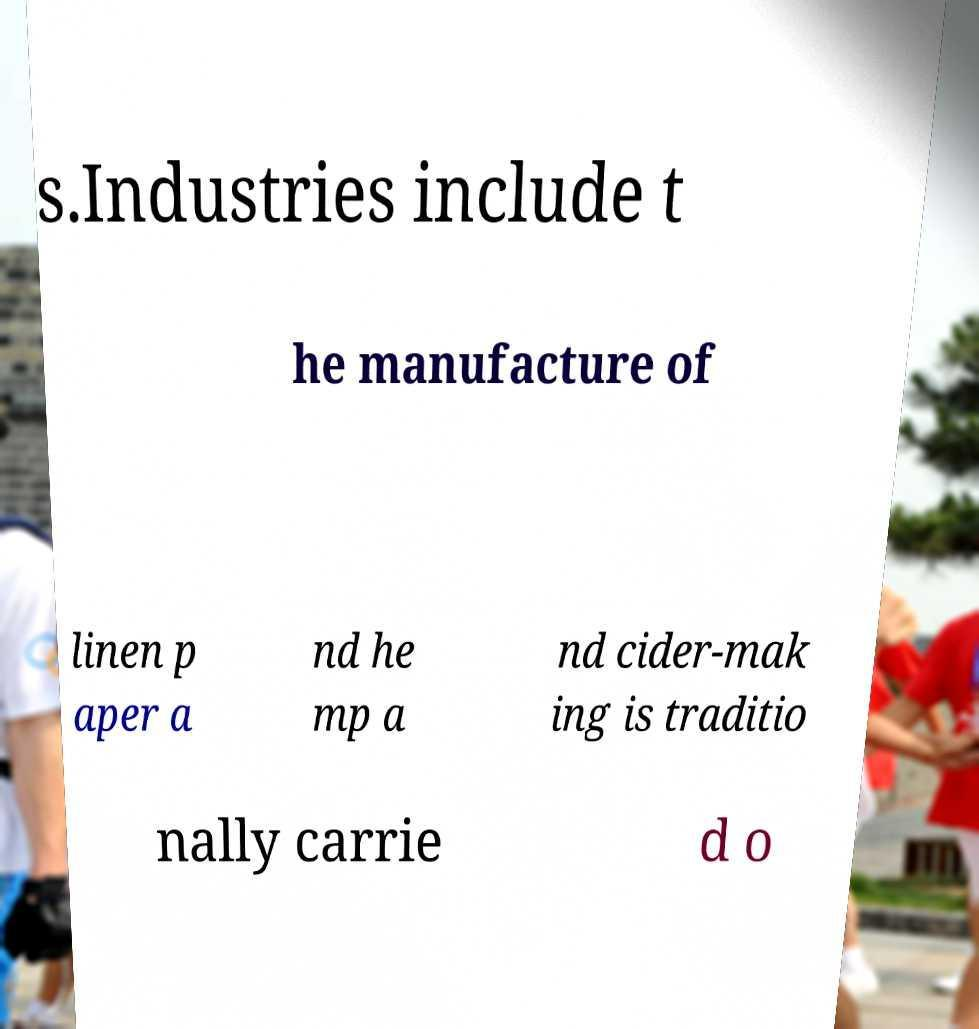For documentation purposes, I need the text within this image transcribed. Could you provide that? s.Industries include t he manufacture of linen p aper a nd he mp a nd cider-mak ing is traditio nally carrie d o 